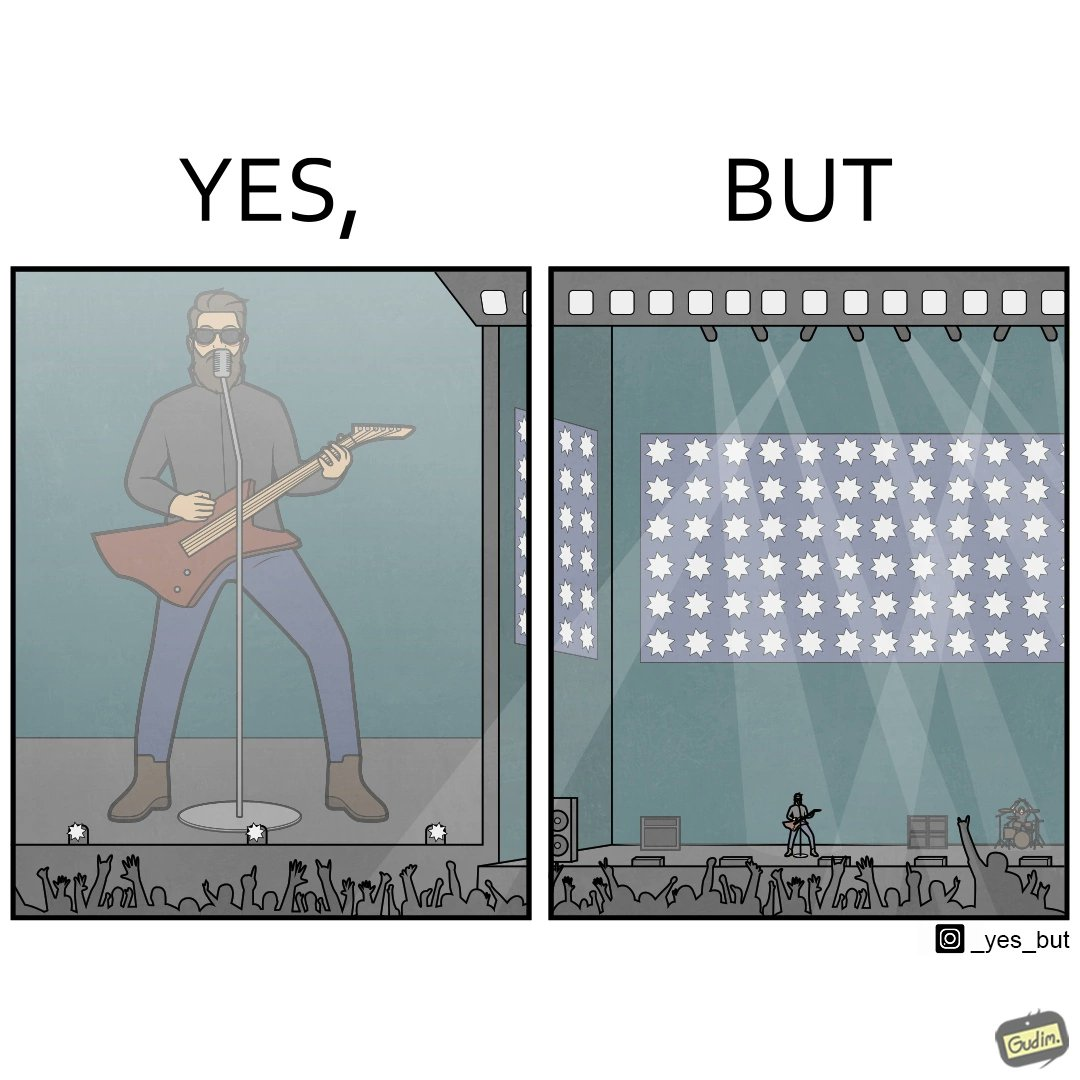What is shown in the left half versus the right half of this image? In the left part of the image: a singer is singing in an orchestra on a stage In the right part of the image: a singer is singing in an orchestra on a stage but the stage is very far from were the image is taken 